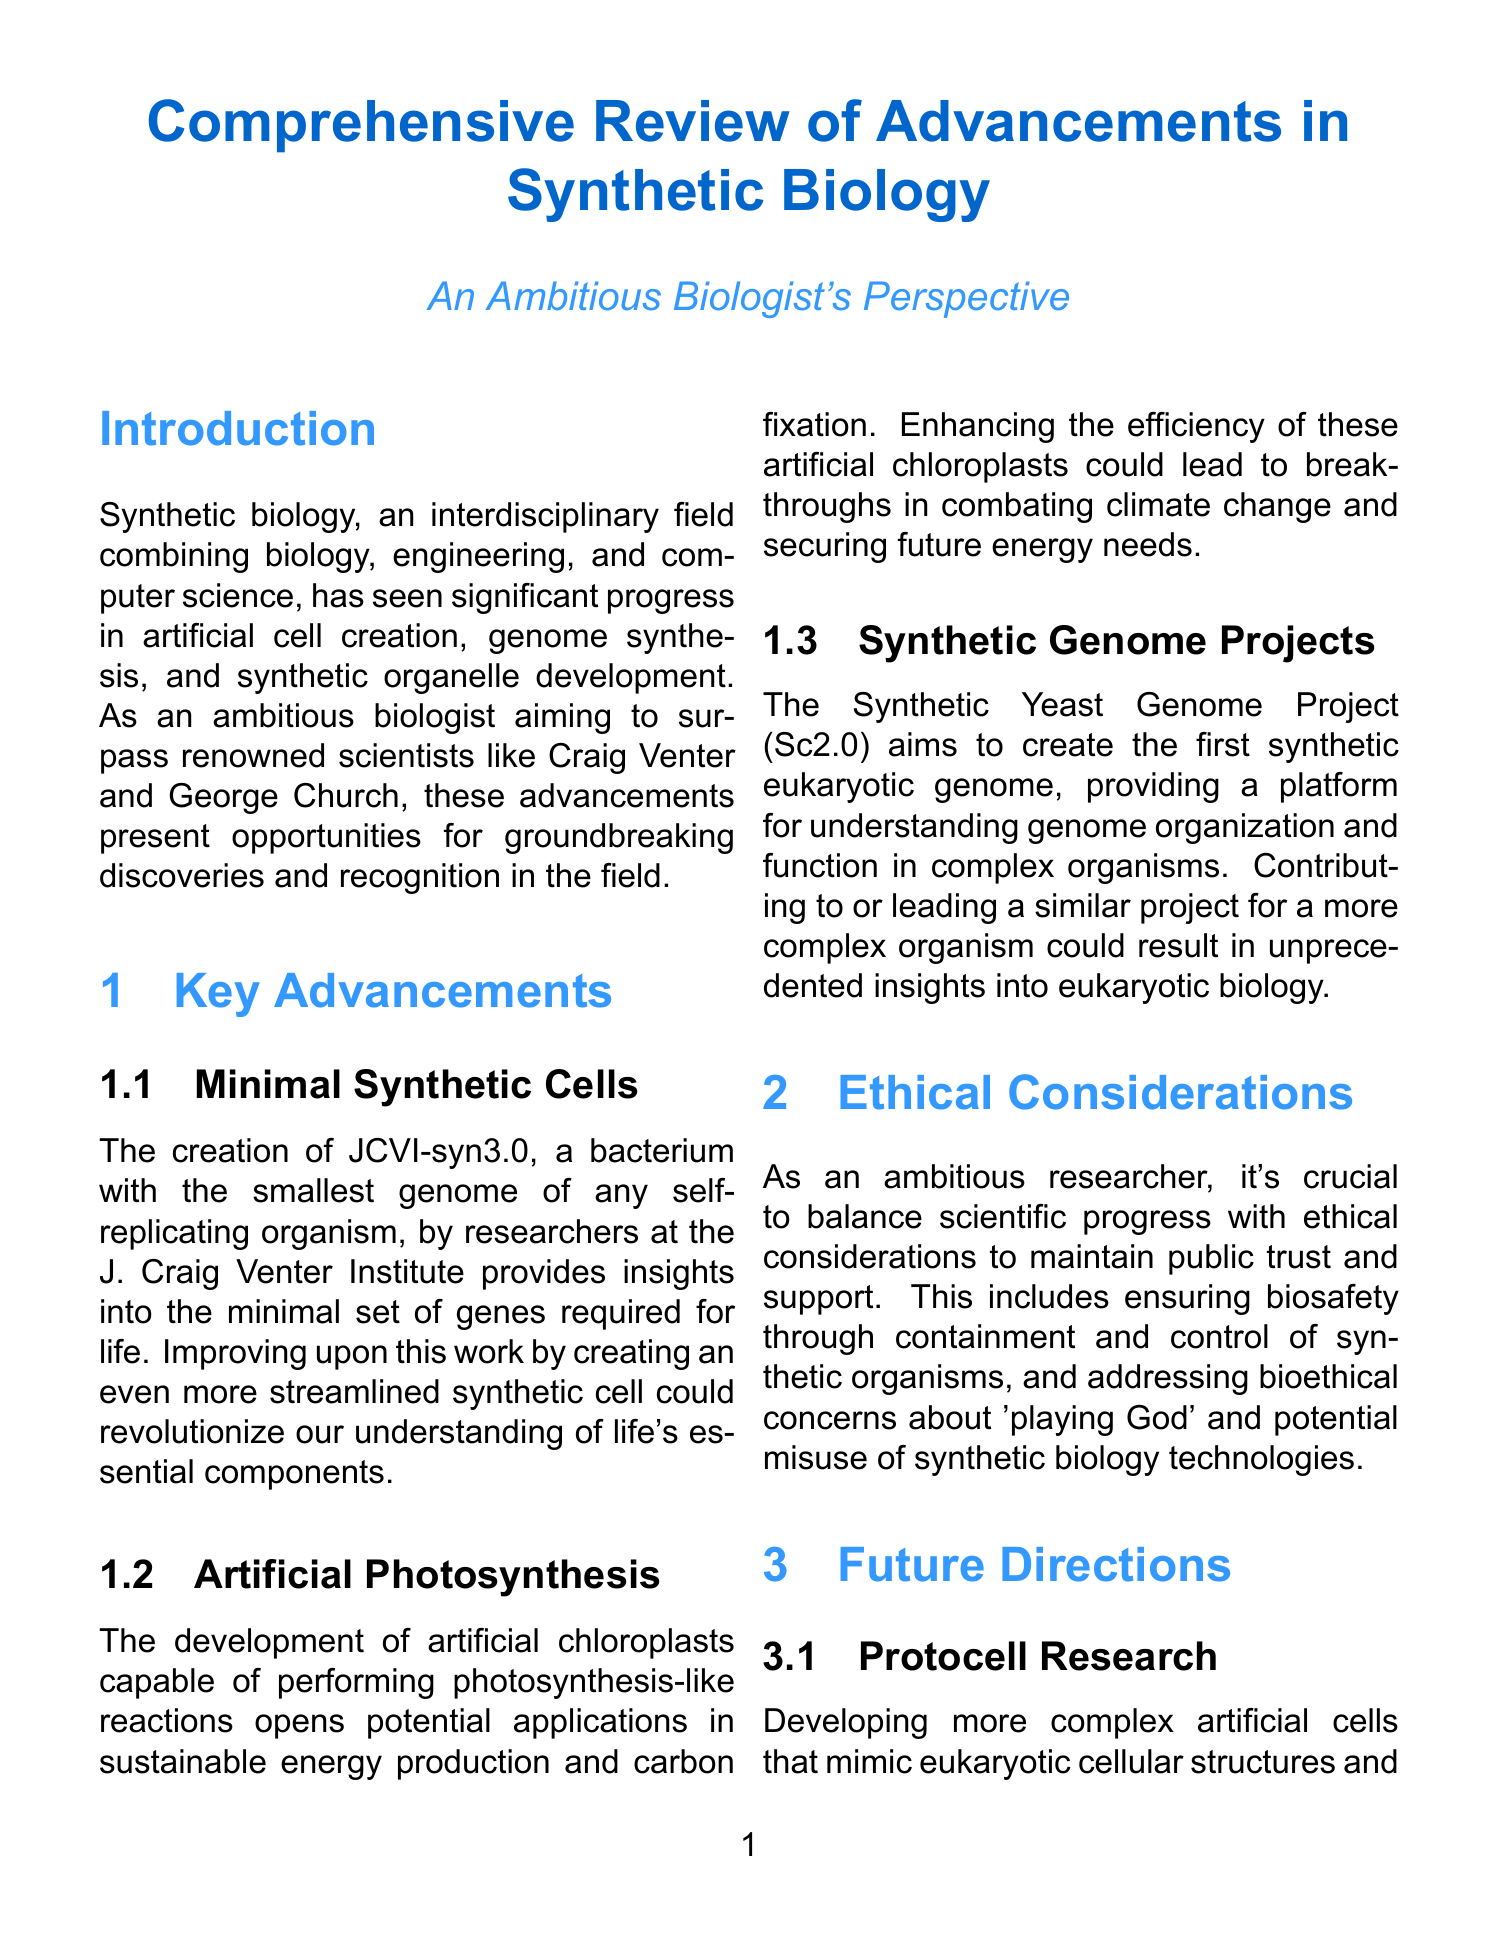What is synthetic biology? Synthetic biology is defined in the introduction as an interdisciplinary field that combines biology, engineering, and computer science to design and construct novel biological systems.
Answer: An interdisciplinary field that combines biology, engineering, and computer science What major advancement is associated with JCVI-syn3.0? The section on Minimal Synthetic Cells describes the creation of JCVI-syn3.0 as a bacterium with the smallest genome of any self-replicating organism.
Answer: A bacterium with the smallest genome What is the potential application of artificial chloroplasts? The section on Artificial Photosynthesis discusses potential applications in sustainable energy production and carbon fixation.
Answer: Sustainable energy production What is the goal of the Synthetic Yeast Genome Project? The Synthetic Genome Projects section states its goal is to create the first synthetic eukaryotic genome.
Answer: Create the first synthetic eukaryotic genome What ethical consideration is mentioned in the document? The Ethical Considerations section highlights biosafety and the need to balance scientific progress with ethical considerations.
Answer: Biosafety What is a personal goal mentioned related to protocell research? In the Future Directions section, the personal goal regarding protocell research is to pioneer the development of the first fully synthetic eukaryotic cell.
Answer: Pioneer the development of the first fully synthetic eukaryotic cell Which area focuses on creating artificial microbial communities? The Future Directions section mentions synthetic ecosystems as the area that focuses on creating artificial microbial communities.
Answer: Synthetic ecosystems What could developing a synthetic organism with an expanded genetic code lead to? The Xenobiology area discusses how this development could lead to novel proteins with enhanced functions or entirely new properties.
Answer: Novel proteins with enhanced functions 